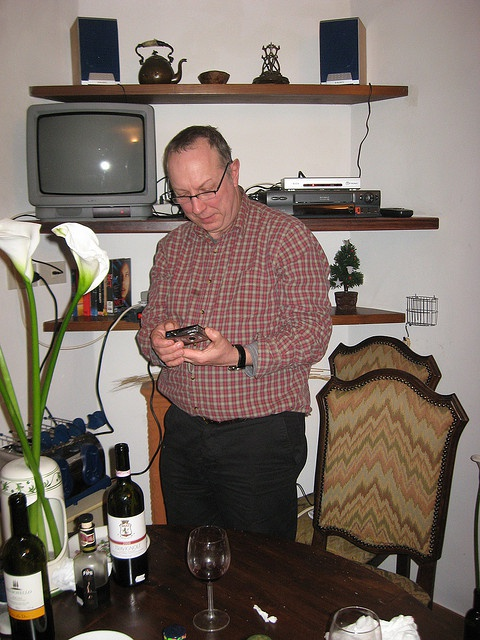Describe the objects in this image and their specific colors. I can see people in gray, brown, and black tones, dining table in gray, black, lightgray, and darkgray tones, chair in gray and black tones, tv in gray and black tones, and tv in gray and black tones in this image. 